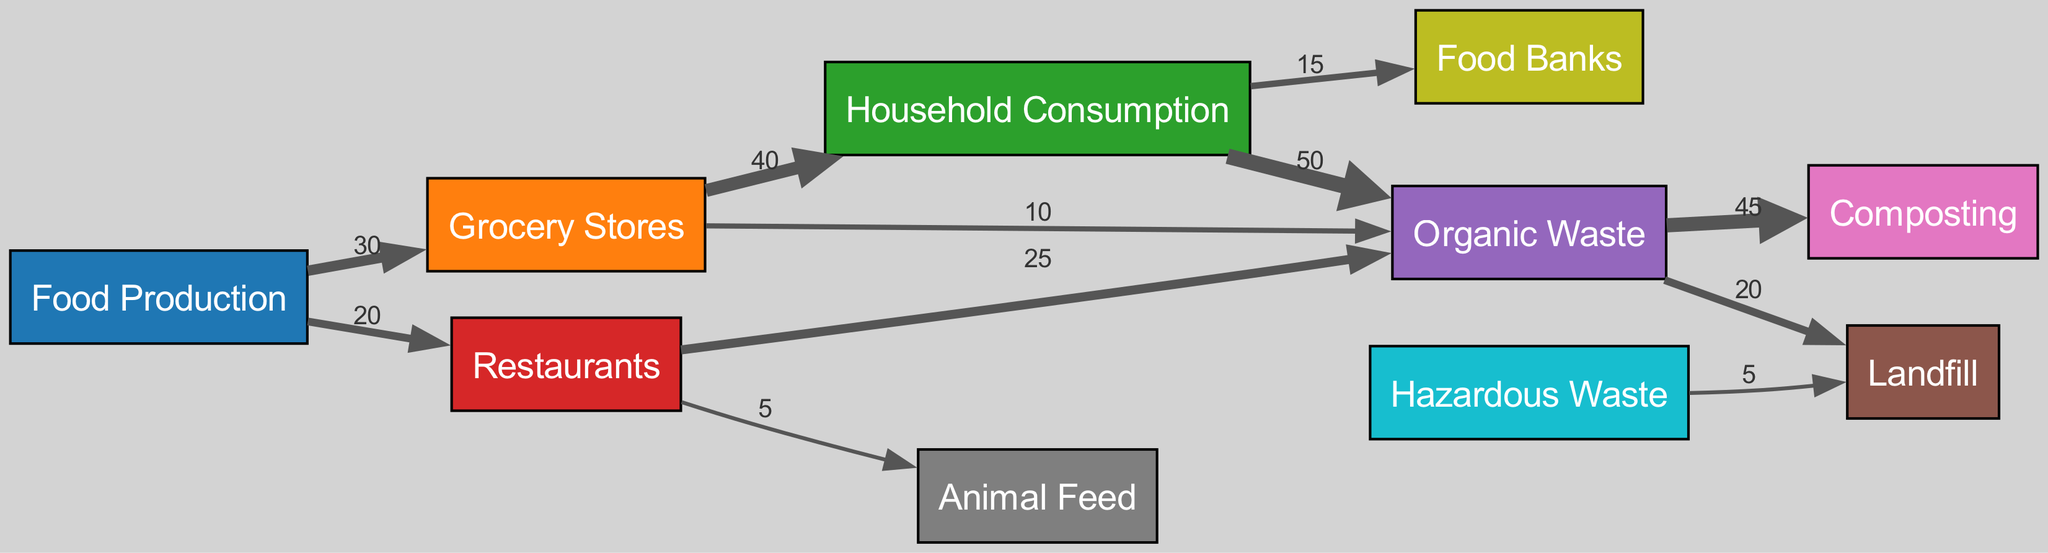What is the total flow of food from Food Production to Grocery Stores? The diagram shows that there is a direct flow of 30 units from Food Production to Grocery Stores. This value is specifically indicated on the connecting line between these two nodes.
Answer: 30 How much food waste is generated by Household Consumption? From Household Consumption, the diagram reveals flows of 50 units of organic waste to Organic Waste and 15 units to Food Banks. Adding these together, the total generated waste from Household Consumption is 50 plus 15, which equals 65.
Answer: 65 What is the total flow from Grocery Stores to Organic Waste? The link from Grocery Stores to Organic Waste shows a value of 10 units. Therefore, the total flow to Organic Waste from Grocery Stores is simply this value.
Answer: 10 Which node receives the most flow from Organic Waste? The Organic Waste node diverts its flow primarily to two destinations. It sends 45 units to Composting and 20 units to Landfill. Since 45 is the highest value, it indicates that Composting receives the most flow.
Answer: Composting What percentage of wasted food from Restaurants goes to Landfill? The Restaurants contribute to organic waste with a flow of 25 units and to Animal Feed with a flow of 5 units. Thus, the total waste from Restaurants is 25 plus 5, equaling 30 units. The waste going to Landfill from Restaurants is 0 units, as they only contribute to Organic Waste and Animal Feed.
Answer: 0 How many total nodes are present in the diagram? By counting the listed nodes in the data provided, we see there are 10 unique nodes including Food Production, Grocery Stores, Household Consumption, Restaurants, Organic Waste, Landfill, Composting, Animal Feed, Food Banks, and Hazardous Waste. Therefore, the total is 10.
Answer: 10 What is the flow of hazardous waste to Landfill? The hazardous waste directly connects to Landfill with a value of 5. The diagram indicates this as the only flow from hazardous waste, confirming that 5 units are sent to Landfill.
Answer: 5 How many units of organic waste are sent for composting? The Organic Waste node directs 45 units to Composting, as observed by the line drawn from Organic Waste to Composting with the corresponding label. This indicates the total amount sent for composting.
Answer: 45 Which food type contributes more to household consumption: Grocery Stores or Restaurants? The flow to Household Consumption from Grocery Stores is 40, while Restaurants have no direct contribution to Household Consumption. Therefore, since Grocery Stores provide 40 units directly to Household Consumption, they are the only contributor.
Answer: Grocery Stores 